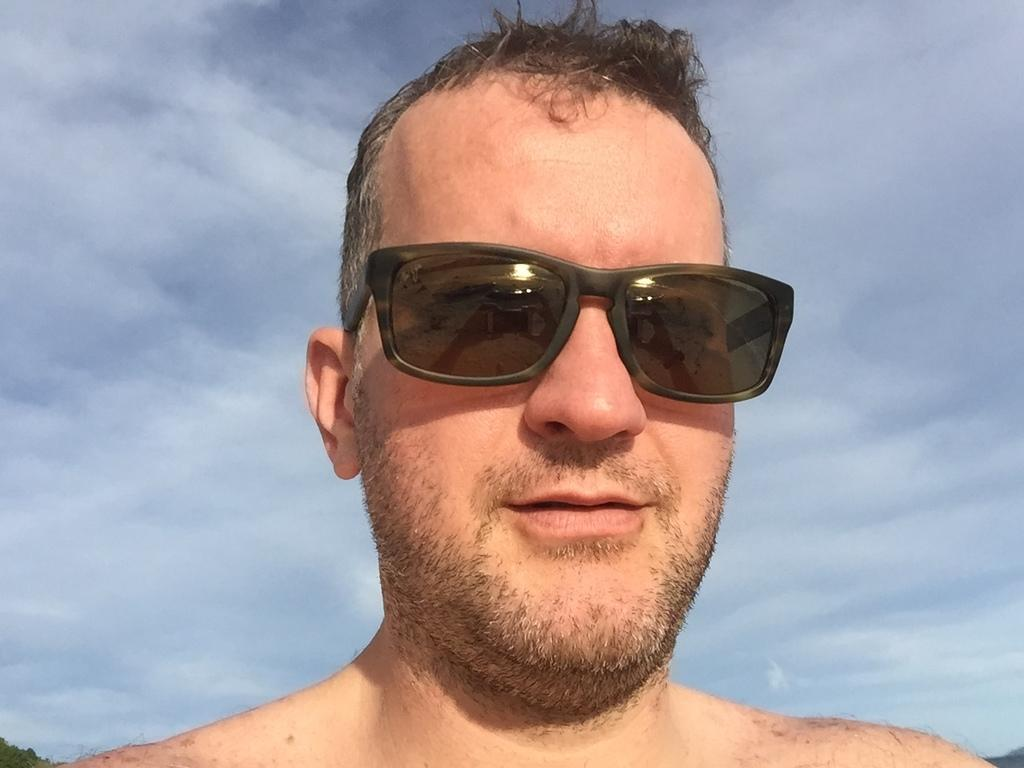What can be seen in the background of the image? The sky is visible in the image. What is the person in the image wearing? The person is wearing goggles in the image. What type of object is partially visible in the image? There is a tree in the image, with its bottom portion truncated. What type of robin can be seen perched on the tree in the image? There is no robin present in the image; the tree is partially visible with its bottom portion truncated. What material is the plastic used for in the image? There is no plastic mentioned or visible in the image. 